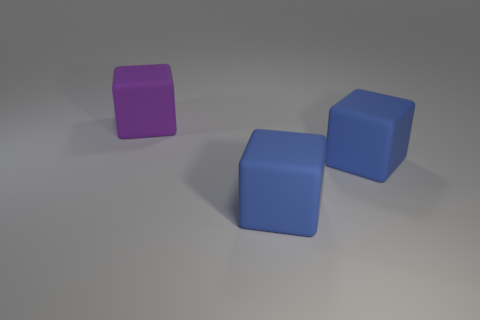Is the number of blocks on the left side of the big purple cube greater than the number of yellow matte things?
Give a very brief answer. No. What number of purple things are large rubber things or balls?
Offer a terse response. 1. Is the number of blue things greater than the number of large yellow blocks?
Provide a short and direct response. Yes. What number of other big objects are the same shape as the purple matte object?
Offer a very short reply. 2. Are there any blue matte objects of the same size as the purple thing?
Give a very brief answer. Yes. How many things are large blue rubber objects or purple matte objects?
Make the answer very short. 3. Are any large cyan things visible?
Your response must be concise. No. There is a large purple thing; are there any matte objects on the right side of it?
Provide a succinct answer. Yes. What number of other things are the same shape as the large purple matte object?
Offer a terse response. 2. Is the number of purple matte things that are on the right side of the purple rubber object less than the number of big rubber cubes?
Offer a very short reply. Yes. 